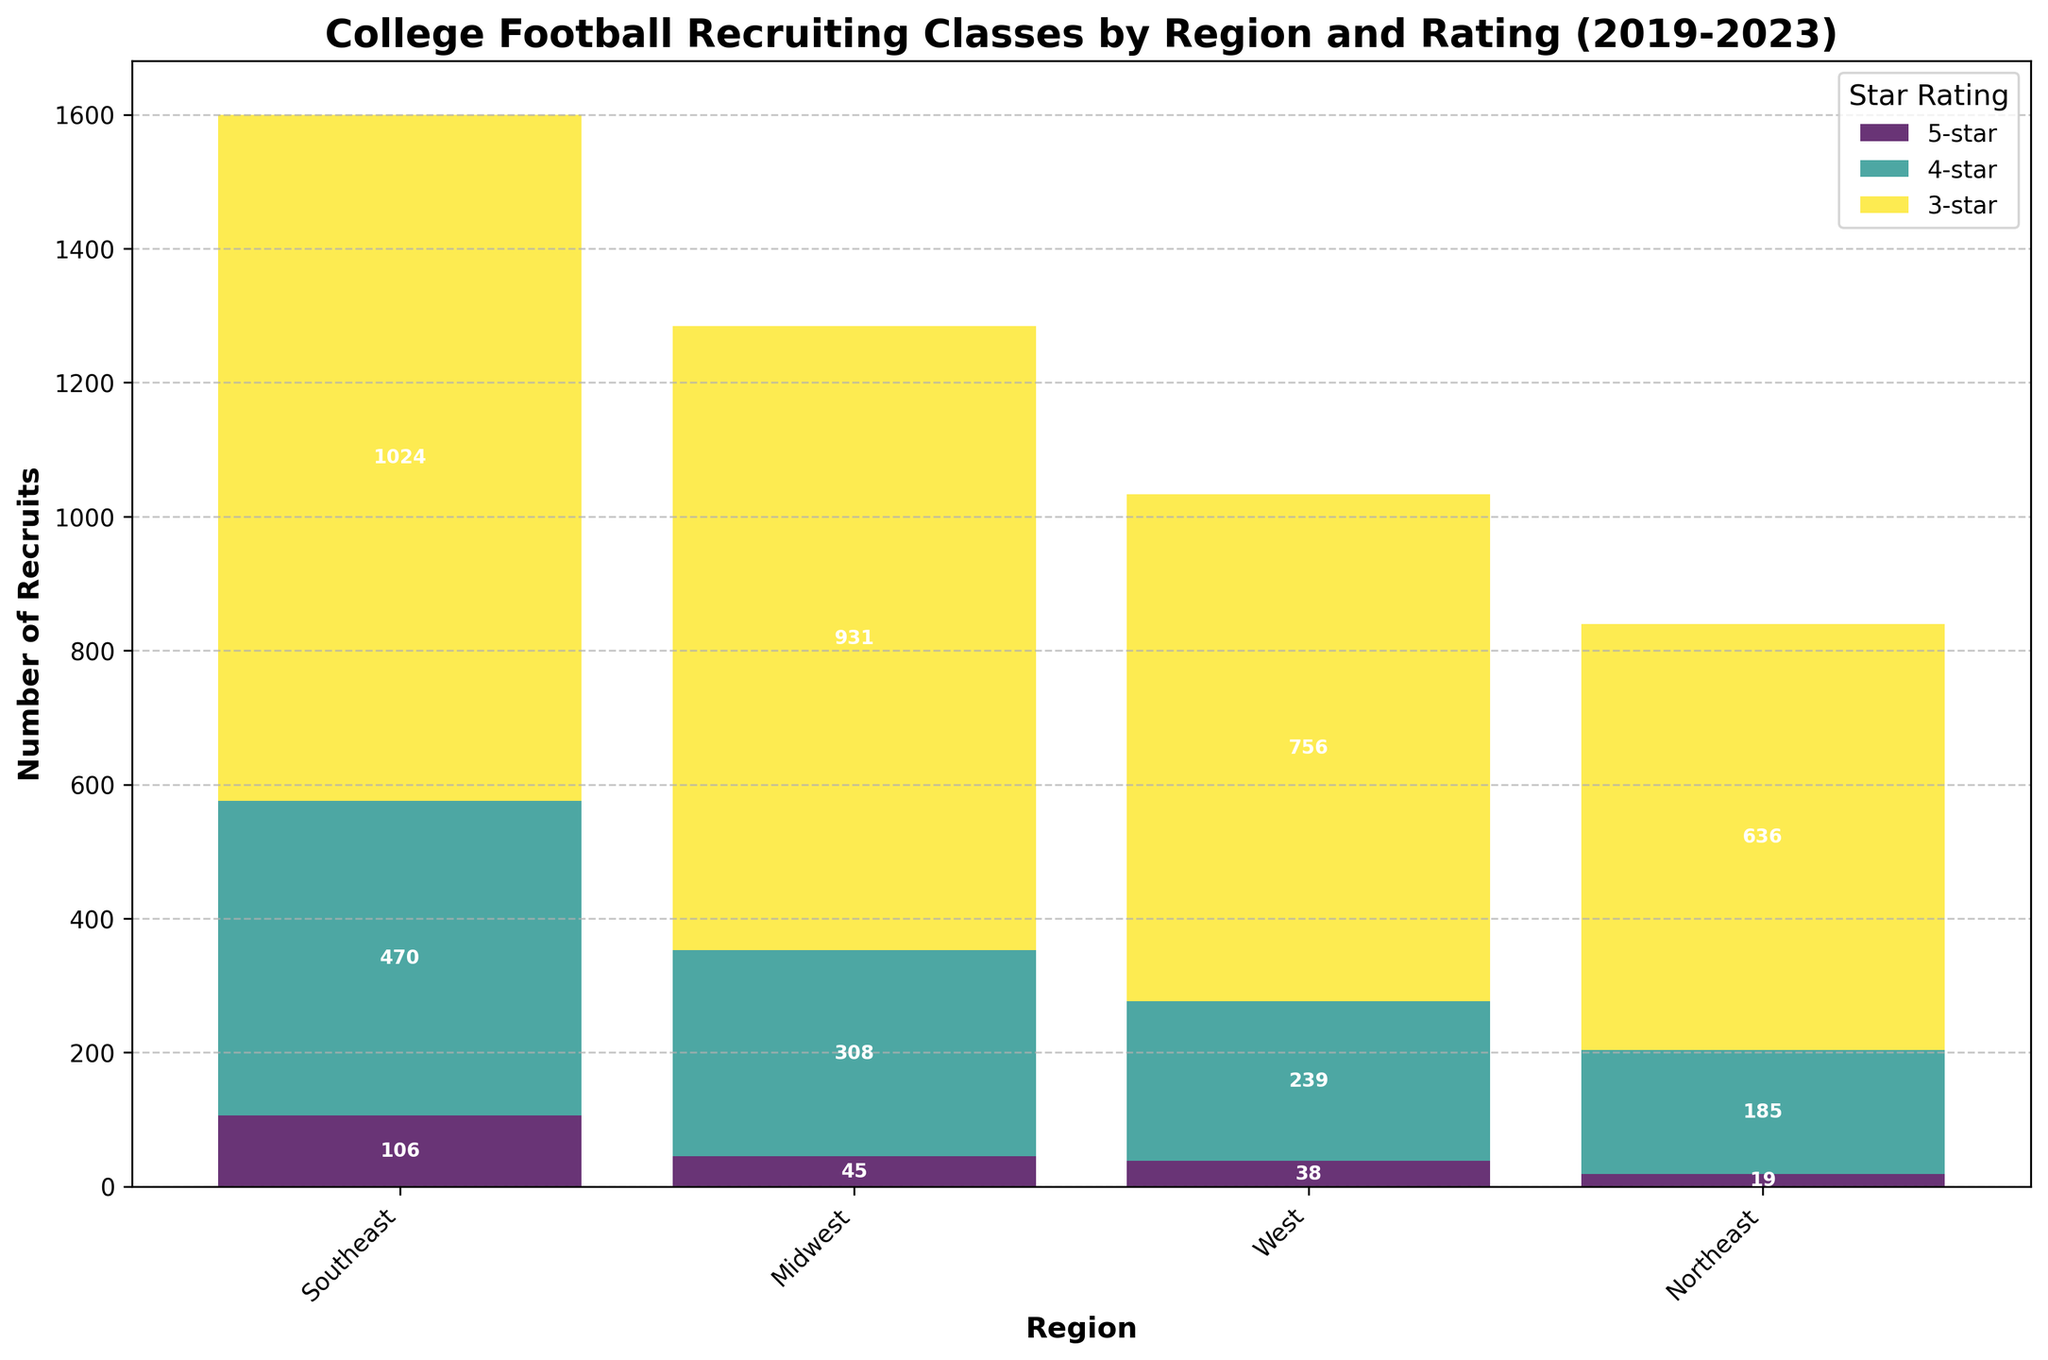Which region has the highest total number of 5-star recruits over the 5-year period? The Southeast region's bar for 5-star recruits is the tallest among all regions. The sum of the values from 2019 to 2023 in the Southeast for 5-star recruits is higher than other regions.
Answer: Southeast Which star rating has the most recruits in the Midwest region? In the Midwest region, the tallest bar segment for each region represents the 3-star recruits, indicating they have the most recruits compared to 4-star and 5-star ratings.
Answer: 3-star How does the total number of 4-star recruits in the West compare to the Southeast? Looking at the bars for the 4-star recruits, the Southeast's segment is significantly larger than the West's segment. This means the total number of 4-star recruits in the Southeast is greater than in the West.
Answer: Southeast > West What is the approximate difference in the total number of 3-star recruits between the Southeast and the Northeast? Summing the heights of the 3-star segments for each year: Southeast (203+198+210+205+208) and Northeast (125+128+130+126+127). The differences are (1024 - 636) = 388.
Answer: 388 Which star rating is the least common across all regions? The 5-star bar segments are generally the smallest across all regions, indicating the 5-star rating is the least common.
Answer: 5-star What region has a relatively consistent number of 3-star recruits over the 5-year period? By observing the 3-star segments, the Northeast region's 3-star bar segments appear fairly consistent in height year-to-year compared to other regions.
Answer: Northeast In which region does the difference between 4-star and 3-star recruits appear the largest? The Southeast region shows a significant height difference between the 4-star and 3-star bar segments, suggesting the largest gap in number between these ratings.
Answer: Southeast How does the total number of 5-star recruits in the Northeast compare to the West? Visually comparing the 5-star segments, the Northeast has shorter bars than the West, indicating fewer 5-star recruits.
Answer: Northeast < West By how much did the total number of 4-star recruits in the Midwest change from 2019 to 2023? Subtracting the 2023 value from the 2019 value in the Midwest for 4-star recruits: 63 - 62 equals a difference of 1.
Answer: 1 